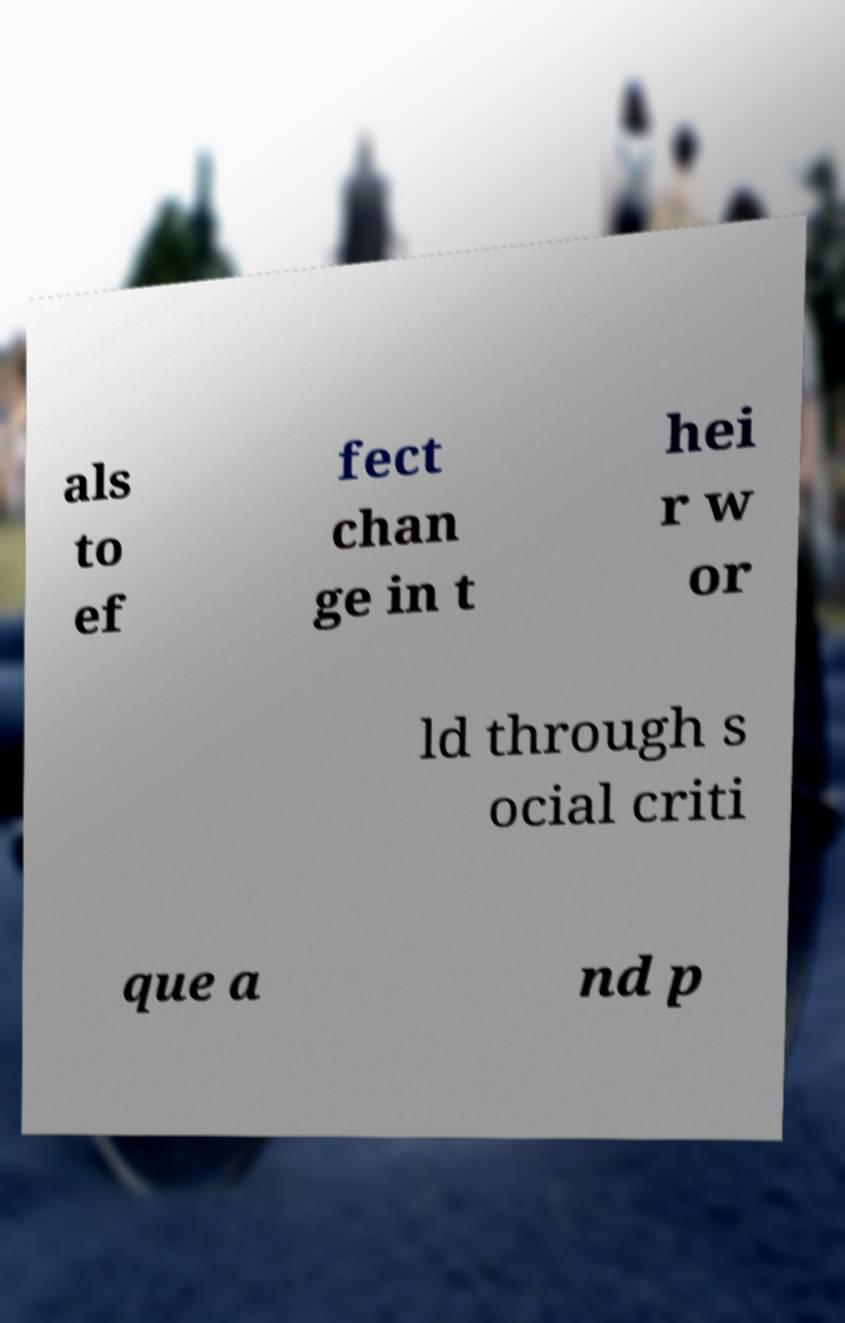Can you read and provide the text displayed in the image?This photo seems to have some interesting text. Can you extract and type it out for me? als to ef fect chan ge in t hei r w or ld through s ocial criti que a nd p 